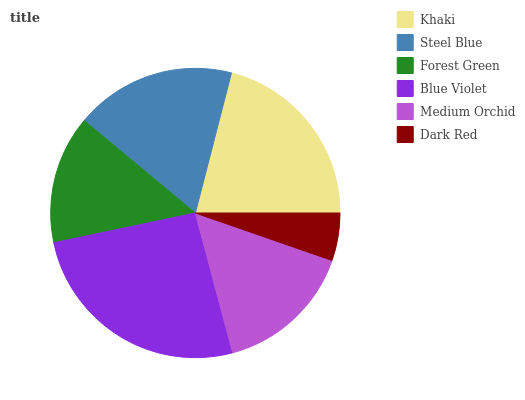Is Dark Red the minimum?
Answer yes or no. Yes. Is Blue Violet the maximum?
Answer yes or no. Yes. Is Steel Blue the minimum?
Answer yes or no. No. Is Steel Blue the maximum?
Answer yes or no. No. Is Khaki greater than Steel Blue?
Answer yes or no. Yes. Is Steel Blue less than Khaki?
Answer yes or no. Yes. Is Steel Blue greater than Khaki?
Answer yes or no. No. Is Khaki less than Steel Blue?
Answer yes or no. No. Is Steel Blue the high median?
Answer yes or no. Yes. Is Medium Orchid the low median?
Answer yes or no. Yes. Is Blue Violet the high median?
Answer yes or no. No. Is Blue Violet the low median?
Answer yes or no. No. 